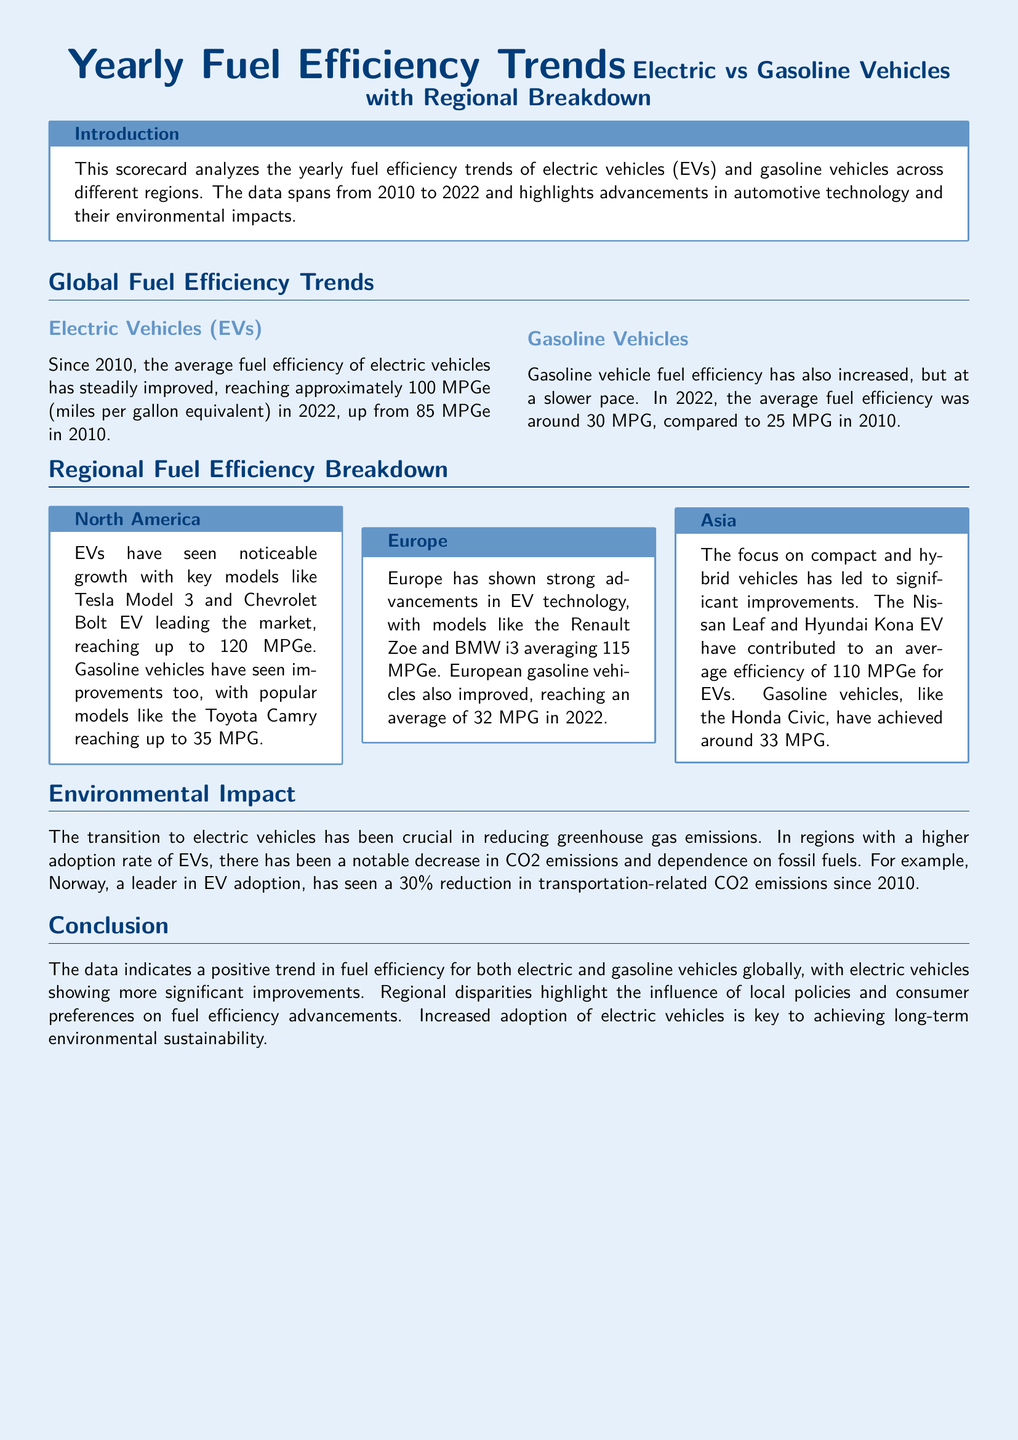what was the average fuel efficiency of electric vehicles in 2022? The document states that the average fuel efficiency of electric vehicles reached approximately 100 MPGe in 2022.
Answer: 100 MPGe what was the average fuel efficiency of gasoline vehicles in 2022? According to the document, the average fuel efficiency of gasoline vehicles was around 30 MPG in 2022.
Answer: 30 MPG which electric vehicle model reached up to 120 MPGe in North America? The document mentions that the Tesla Model 3 reached up to 120 MPGe in North America.
Answer: Tesla Model 3 what percentage reduction in CO2 emissions has Norway seen since 2010? The document states that Norway has seen a 30% reduction in transportation-related CO2 emissions since 2010.
Answer: 30% which region has the lowest average fuel efficiency for gasoline vehicles in 2022? The document does not specify exact comparisons, but it implies that Asia has a gasoline vehicle average of around 33 MPG, which is lower than North America and Europe but does not present direct comparison metrics. Thus, reasoned analysis leads to Asia as an acceptable answer.
Answer: Asia what was the average fuel efficiency of gasoline vehicles in Europe in 2022? The document notes that European gasoline vehicles improved, reaching an average of 32 MPG in 2022.
Answer: 32 MPG which EV model in Asia averaged 110 MPGe? The document mentions that the Nissan Leaf averaged 110 MPGe in Asia.
Answer: Nissan Leaf what year range does the analyzed data span? The document indicates that the data spans from 2010 to 2022.
Answer: 2010 to 2022 what is the trend in fuel efficiency for electric vehicles since 2010? The document states that the average fuel efficiency of electric vehicles has steadily improved since 2010.
Answer: Improved 